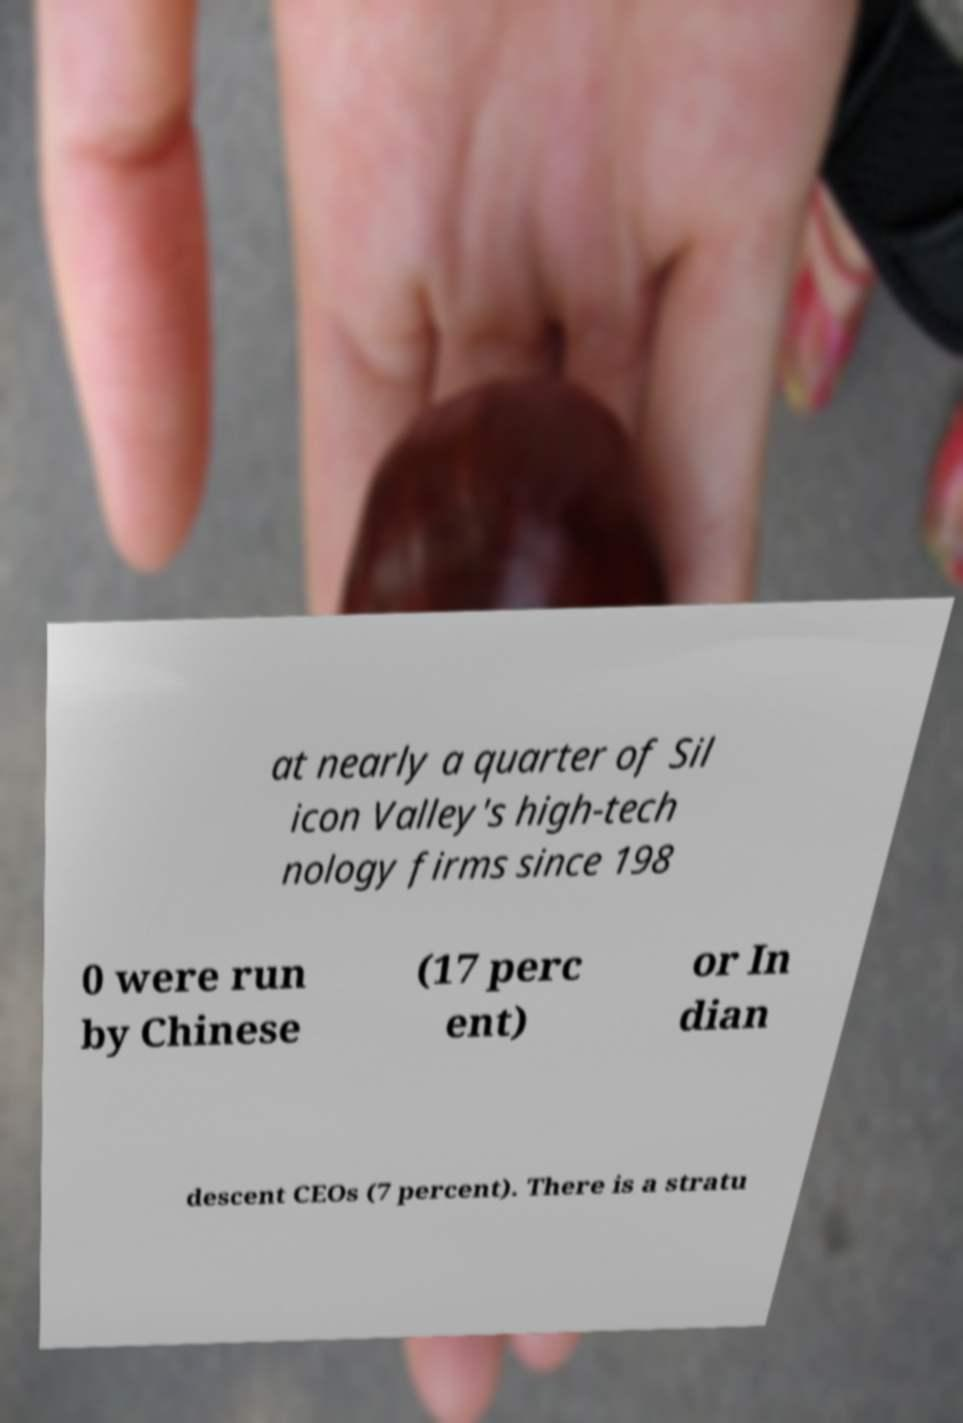Can you read and provide the text displayed in the image?This photo seems to have some interesting text. Can you extract and type it out for me? at nearly a quarter of Sil icon Valley's high-tech nology firms since 198 0 were run by Chinese (17 perc ent) or In dian descent CEOs (7 percent). There is a stratu 